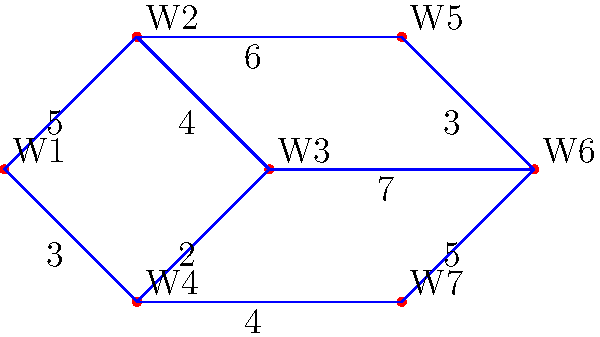In a factory, seven workstations (W1 to W7) are connected as shown in the graph. The edges represent paths between workstations, and the numbers on the edges indicate the average number of times workers move between stations per hour. To optimize the factory layout, you need to identify the minimum spanning tree (MST) that connects all workstations. What is the total weight of the MST? To find the minimum spanning tree (MST) of this graph, we can use Kruskal's algorithm. Here's the step-by-step process:

1. Sort all edges by weight in ascending order:
   (2,3): 2
   (4,5): 3
   (0,3): 3
   (1,2): 4
   (3,6): 4
   (0,1): 5
   (5,6): 5
   (1,4): 6
   (2,5): 7

2. Start with an empty MST and add edges in order, skipping those that would create a cycle:
   - Add (2,3): 2
   - Add (4,5): 3
   - Add (0,3): 3
   - Add (1,2): 4
   - Add (3,6): 4
   - Add (0,1): 5 (completes the MST)

3. The MST now includes 6 edges (number of vertices - 1), connecting all 7 workstations.

4. Calculate the total weight of the MST:
   $$2 + 3 + 3 + 4 + 4 + 5 = 21$$

Therefore, the total weight of the minimum spanning tree is 21.
Answer: 21 